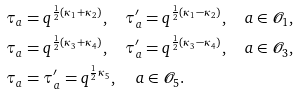Convert formula to latex. <formula><loc_0><loc_0><loc_500><loc_500>\tau _ { a } & = q ^ { \frac { 1 } { 2 } ( \kappa _ { 1 } + \kappa _ { 2 } ) } , \quad \tau _ { a } ^ { \prime } = q ^ { \frac { 1 } { 2 } ( \kappa _ { 1 } - \kappa _ { 2 } ) } , \quad a \in \mathcal { O } _ { 1 } , \\ \tau _ { a } & = q ^ { \frac { 1 } { 2 } ( \kappa _ { 3 } + \kappa _ { 4 } ) } , \quad \tau _ { a } ^ { \prime } = q ^ { \frac { 1 } { 2 } ( \kappa _ { 3 } - \kappa _ { 4 } ) } , \quad a \in \mathcal { O } _ { 3 } , \\ \tau _ { a } & = \tau _ { a } ^ { \prime } = q ^ { \frac { 1 } { 2 } \kappa _ { 5 } } , \quad \, a \in \mathcal { O } _ { 5 } .</formula> 